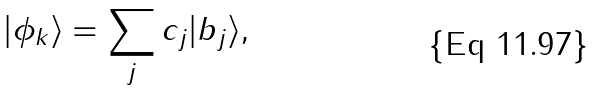<formula> <loc_0><loc_0><loc_500><loc_500>| \phi _ { k } \rangle = \sum _ { j } c _ { j } | b _ { j } \rangle ,</formula> 